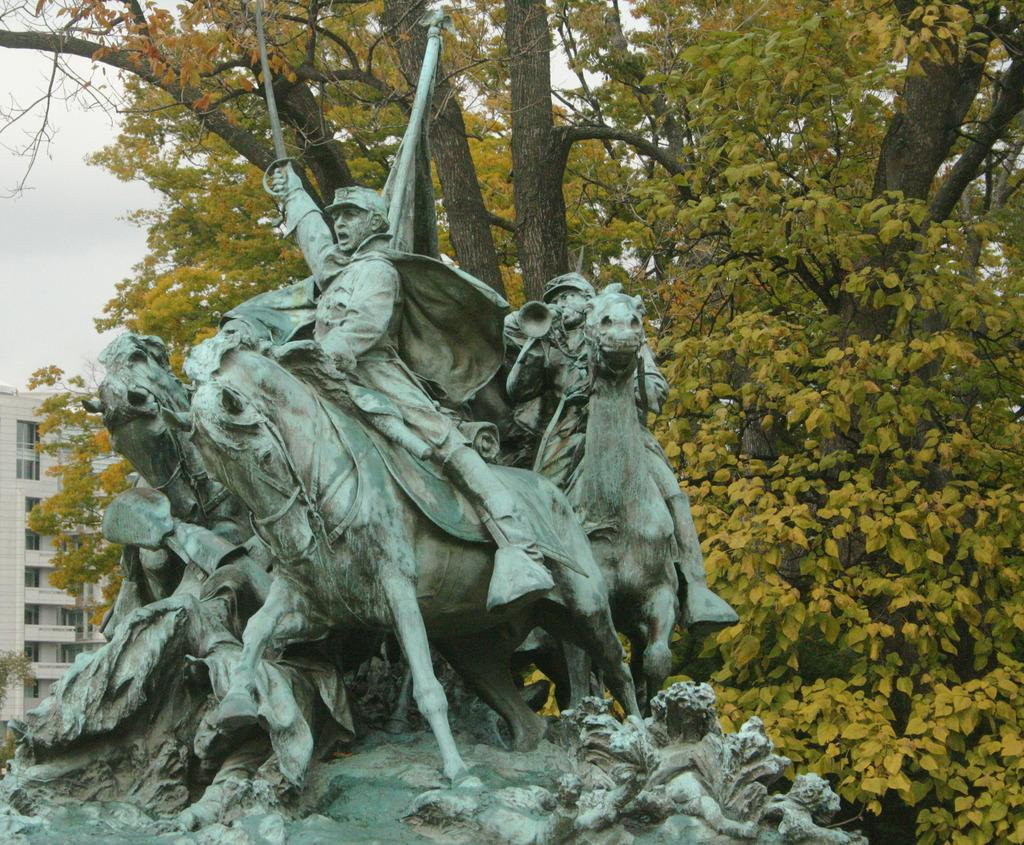What is the main subject in the image? There is a statue in the image. What can be seen in the background of the image? There is a building and trees in the background of the image. What is visible in the sky in the image? The sky is visible in the background of the image. How many boys are learning to play the wren in the image? There are no boys or wrens present in the image. What type of learning activity is taking place with the boys and the wren in the image? There is no learning activity involving boys and a wren in the image, as there are no boys or wrens present. 